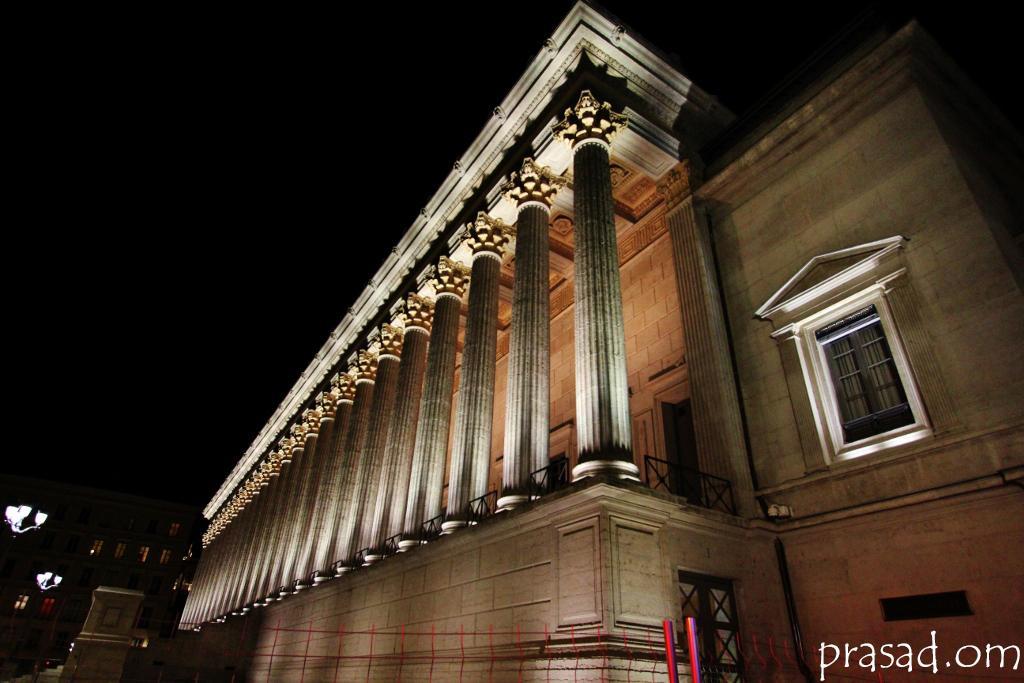How would you summarize this image in a sentence or two? In this image, we can see buildings and lights and there is a fence. At the bottom, there is some text. 